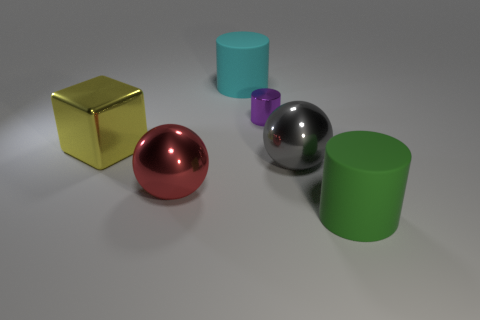Add 2 large red objects. How many objects exist? 8 Subtract all balls. How many objects are left? 4 Subtract all large cyan matte balls. Subtract all big cyan things. How many objects are left? 5 Add 2 large yellow things. How many large yellow things are left? 3 Add 4 large yellow metallic blocks. How many large yellow metallic blocks exist? 5 Subtract 0 blue blocks. How many objects are left? 6 